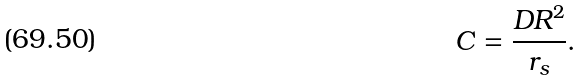Convert formula to latex. <formula><loc_0><loc_0><loc_500><loc_500>C = \frac { D R ^ { 2 } } { r _ { s } } .</formula> 